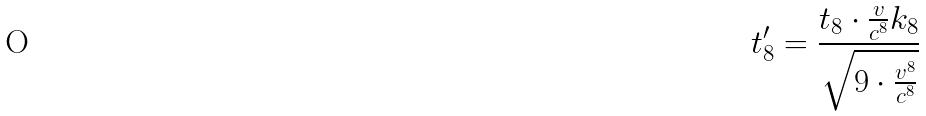<formula> <loc_0><loc_0><loc_500><loc_500>t _ { 8 } ^ { \prime } = \frac { t _ { 8 } \cdot \frac { v } { c ^ { 8 } } k _ { 8 } } { \sqrt { 9 \cdot \frac { v ^ { 8 } } { c ^ { 8 } } } }</formula> 